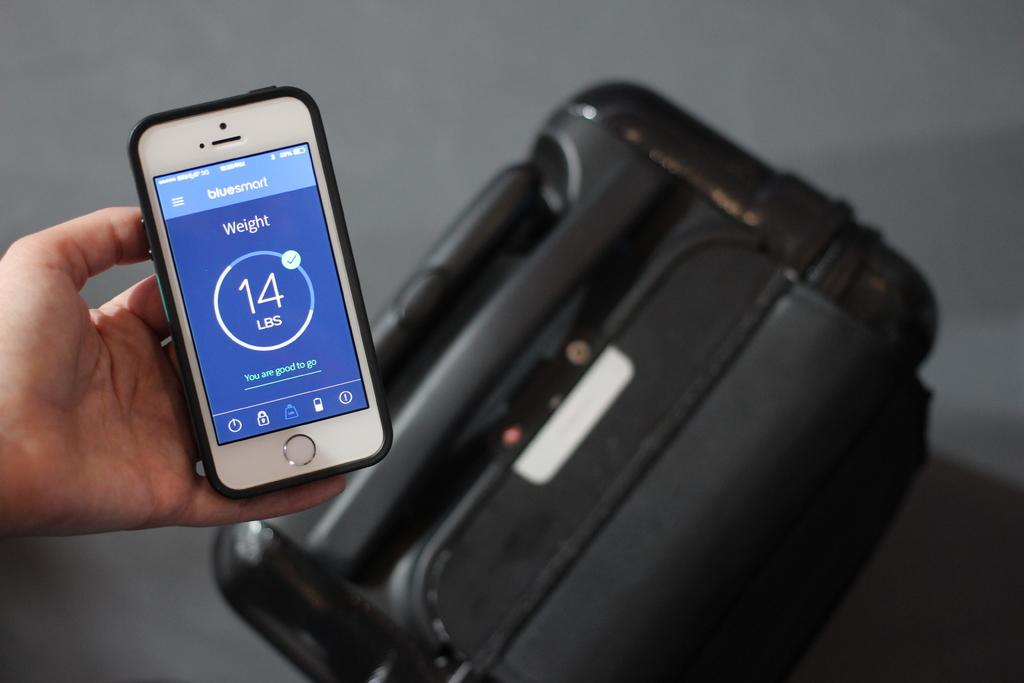<image>
Offer a succinct explanation of the picture presented. The weight of the luggage displayed on the cellphone is 14 lbs. 